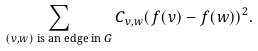<formula> <loc_0><loc_0><loc_500><loc_500>\sum _ { ( v , w ) \text { is an edge in $G$} } { C _ { v , w } ( f ( v ) - f ( w ) ) ^ { 2 } } .</formula> 